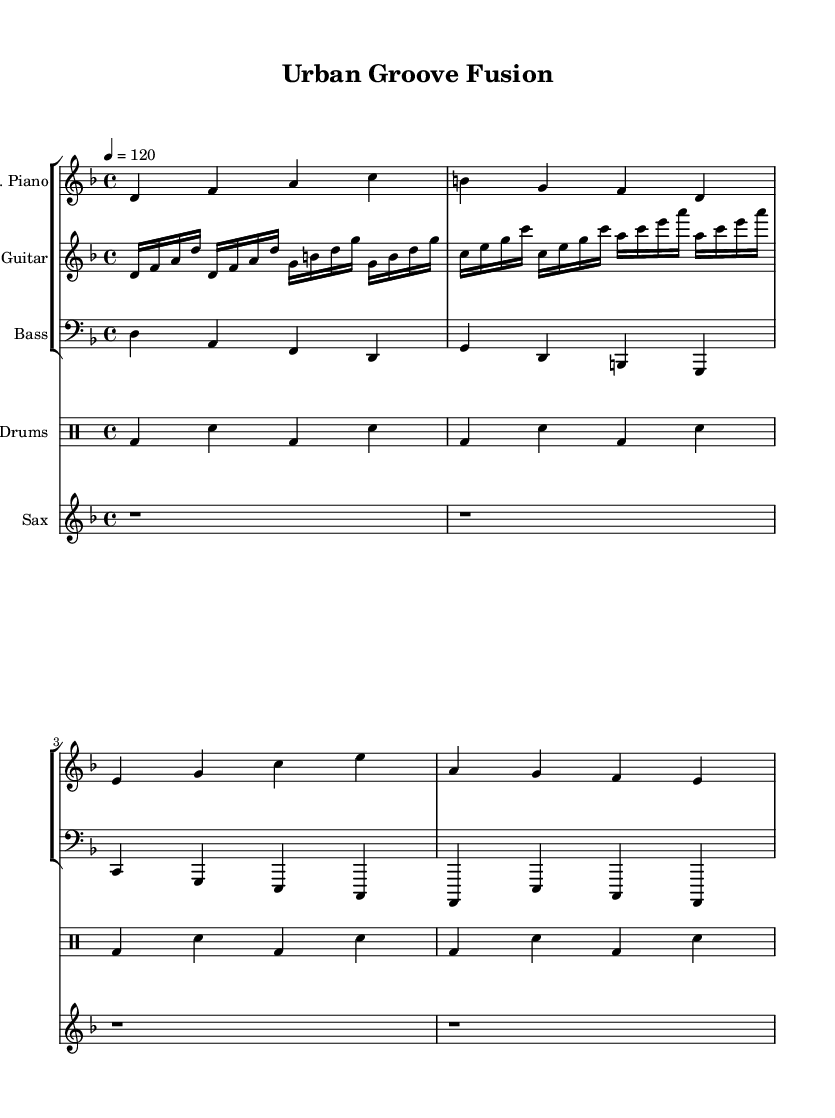What is the key signature of this music? The key signature is D minor, which has one flat (B flat). It is indicated at the beginning of the staff.
Answer: D minor What is the time signature used in this piece? The time signature is 4/4, indicated at the beginning of the score. This means there are four beats in each measure and a quarter note gets one beat.
Answer: 4/4 What is the tempo marking for this composition? The tempo marking indicates a moderate pace of 120 beats per minute, which is specified in the score.
Answer: 120 Which instruments are featured in this composition? The instruments included are electric piano, electric guitar, bass guitar, drums, and saxophone. Each is labeled at the beginning of its respective staff.
Answer: Electric piano, electric guitar, bass guitar, drums, saxophone How many measures does the electric piano part have in this segment? The electric piano part has four measures, indicated by the four-bar grouping. The measures begin with the first note and end where the next line would begin.
Answer: Four measures Is there a drum pattern present in the sheet music? Yes, the drum pattern is clearly notated in the drum staff section using common drum notation that specifies bass drum and snare hits.
Answer: Yes 